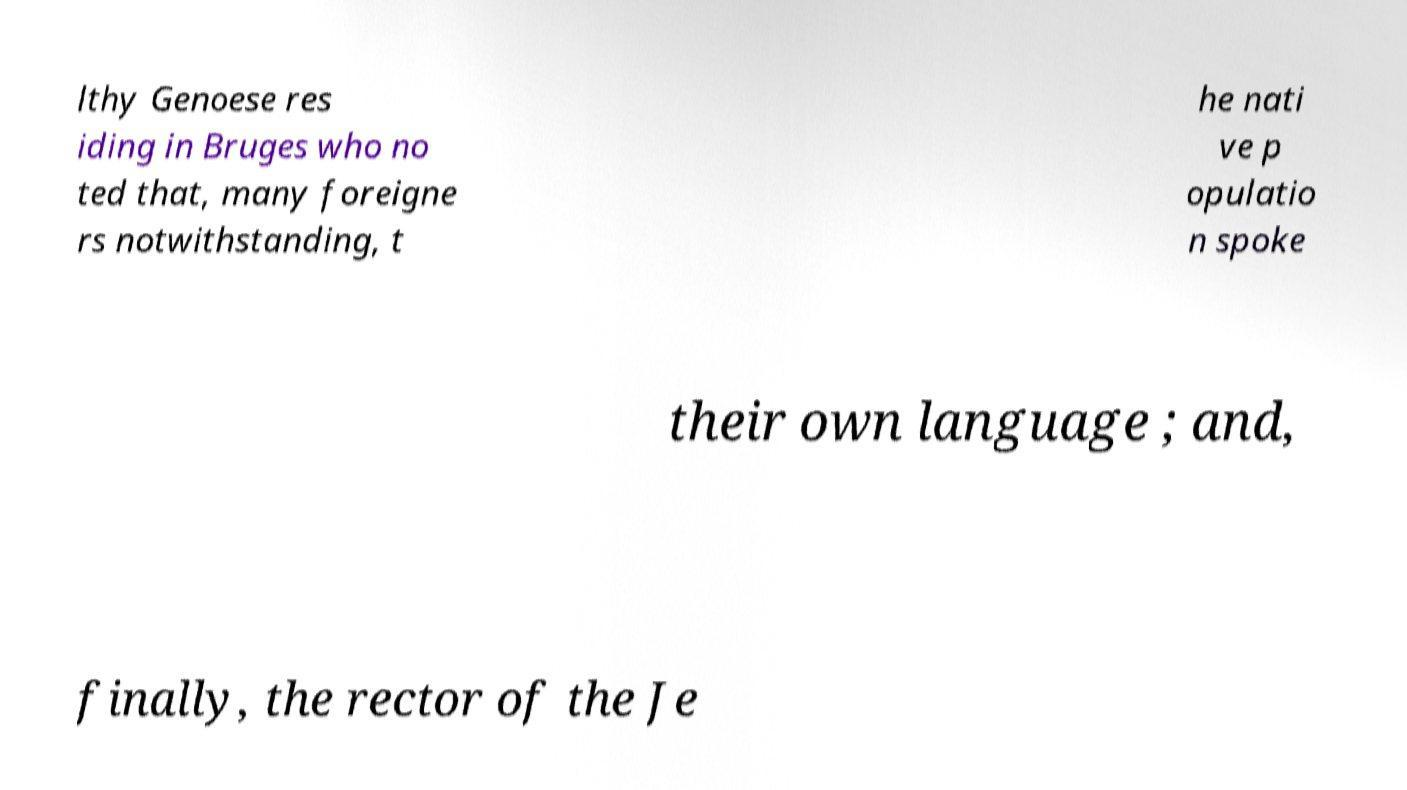Can you read and provide the text displayed in the image?This photo seems to have some interesting text. Can you extract and type it out for me? lthy Genoese res iding in Bruges who no ted that, many foreigne rs notwithstanding, t he nati ve p opulatio n spoke their own language ; and, finally, the rector of the Je 